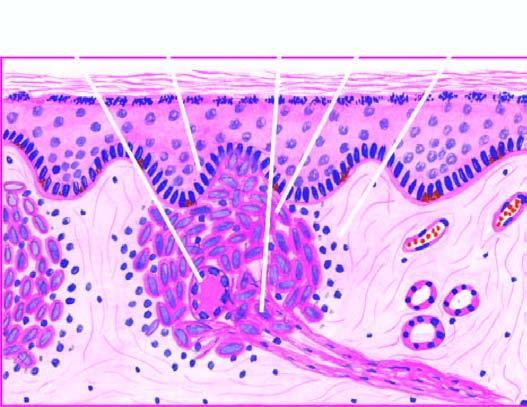s necrosis composed of epithelioid cells with sparse langhans ' giant cells and lymphocytes?
Answer the question using a single word or phrase. No 